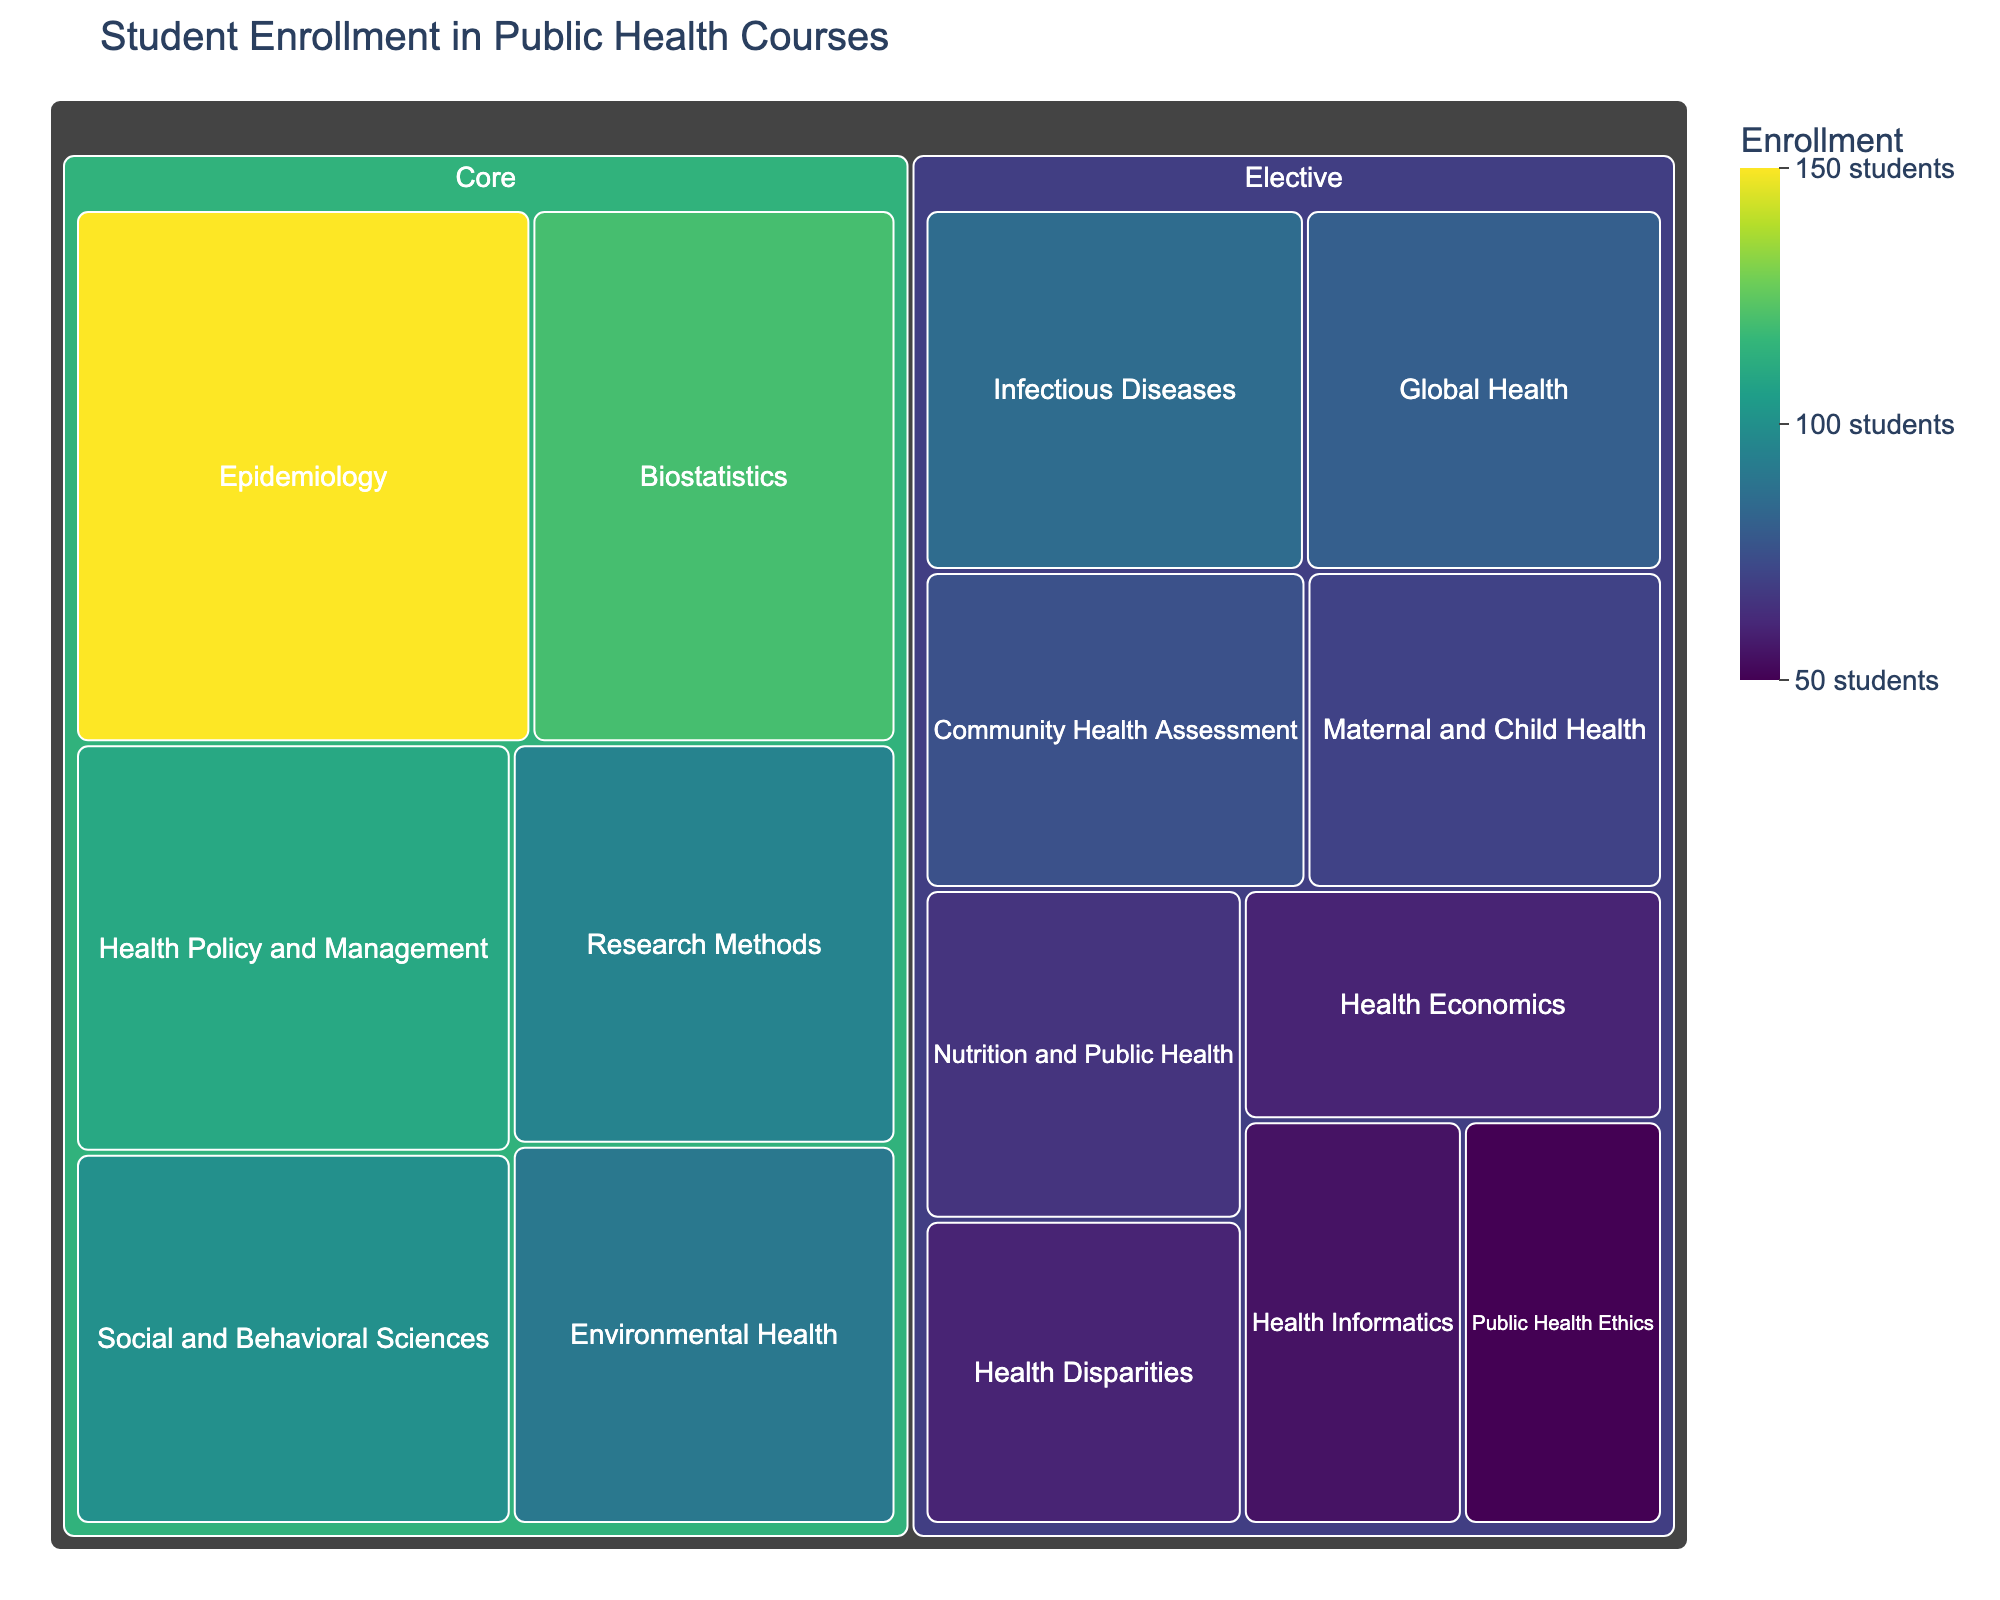What's the title of the treemap? The title is usually prominently displayed at the top of the figure. In this case, it states the overall purpose of the figure.
Answer: Student Enrollment in Public Health Courses How many core courses are listed in the treemap? Core courses are grouped under the "Core" category. By counting the courses within this group, we can determine the number of core courses.
Answer: Six Which course has the highest enrollment? The course with the largest area (and hence the highest enrollment figure) will be easily identifiable on the treemap as having the largest colored block.
Answer: Epidemiology Which category, Core or Elective, has the higher cumulative enrollment? To find this, we need to sum the enrollments for all courses in each category (Core and Elective) and compare the two sums.
Answer: Core What is the enrollment difference between the courses with the highest and the lowest enrollments? The course with the highest enrollment is Epidemiology with 150 students. The course with the lowest enrollment is Public Health Ethics with 50 students. The difference in enrollment is calculated by subtracting the smaller number from the larger one.
Answer: 100 Which Core course has the lowest enrollment? Among the Core courses, the one with the smallest area/block represents the lowest enrollment.
Answer: Environmental Health In which category does the course with the second-highest enrollment belong? The course with the second-highest enrollment can be identified by sorting the blocks by size and finding the second largest. Then, we look at which category this course is listed under.
Answer: Core (Biostatistics) What is the average enrollment for Core courses? First, sum the enrollments for all Core courses: 150 (Epidemiology) + 120 (Biostatistics) + 90 (Environmental Health) + 110 (Health Policy and Management) + 100 (Social and Behavioral Sciences) + 95 (Research Methods) = 665. Then divide by the number of Core courses, which is six.
Answer: Approximately 111 Among Elective courses, which two courses have the closest enrollment numbers? By examining the values for Elective courses, we can identify two courses with similar enrollment figures.
Answer: Health Economics and Health Disparities (both 60) What is the total enrollment for all courses depicted in the treemap? Sum the enrollments for all courses listed in the treemap: 150 + 120 + 90 + 110 + 100 + 80 + 60 + 70 + 85 + 55 + 65 + 75 + 50 + 60 + 95
Answer: 1265 